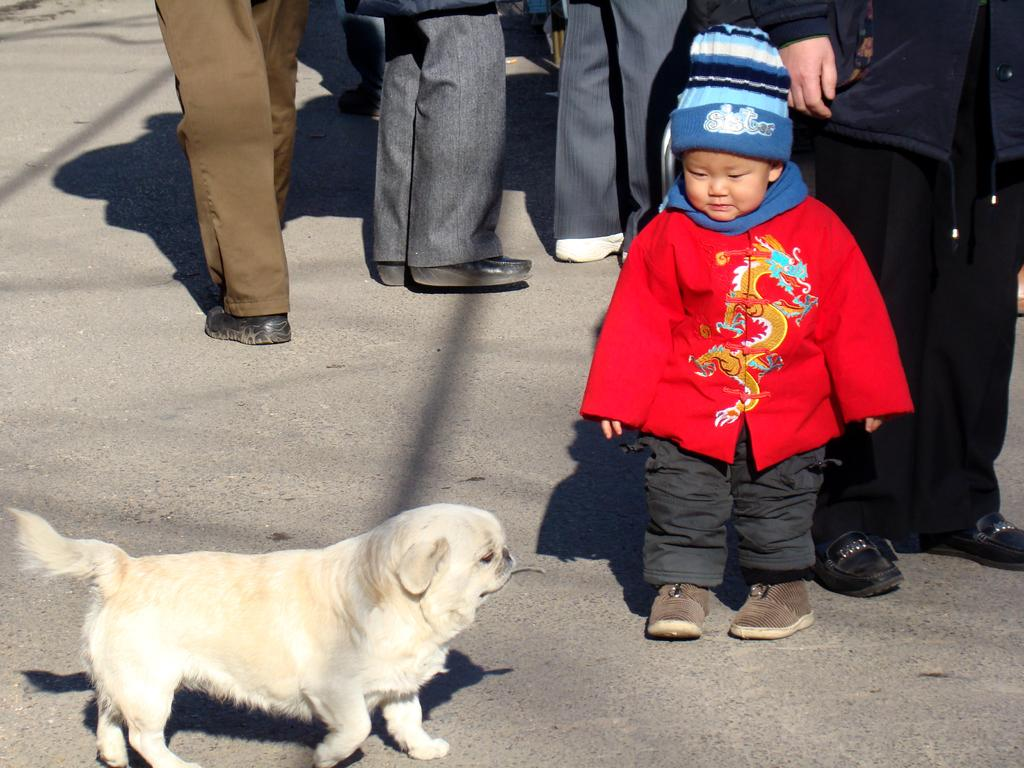What type of animal is in the image? There is a dog in the image. Who else is present in the image? There is a child in the image. What part of people can be seen in the image? People's feet are visible in the image. What type of brick is being used to create an impulse in the image? There is no brick or impulse present in the image; it features a dog and a child. 